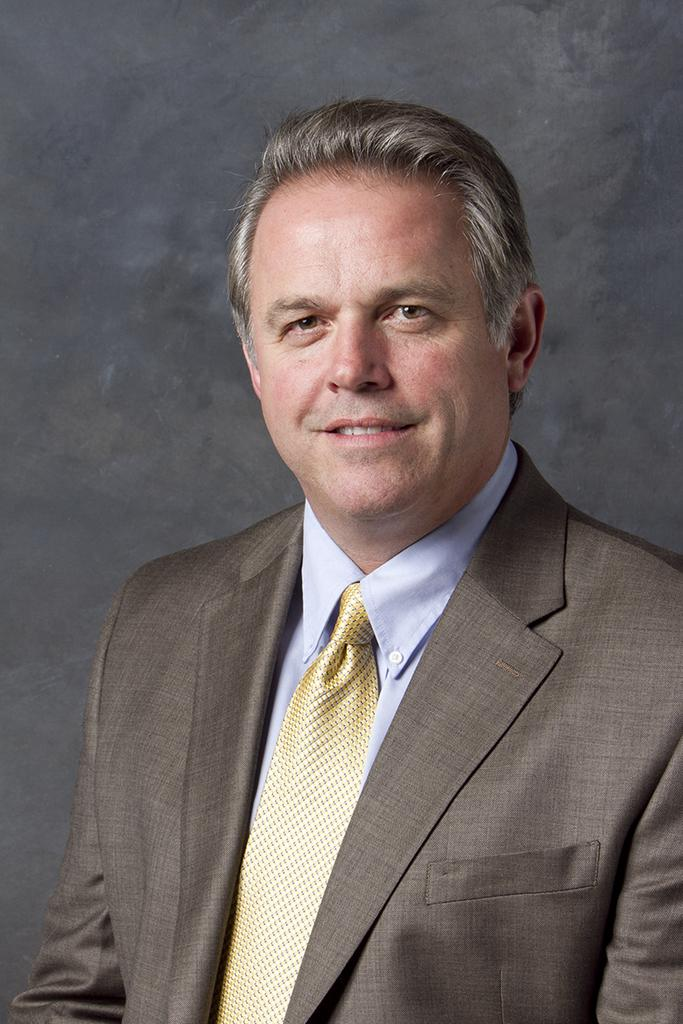What is the main subject of the image? The main subject of the image is a man. What is the man wearing? The man is wearing a brown suit, a golden tie, and a blue shirt. How is the man's facial expression in the image? The man is smiling in the image. What type of string is the man using to secure his payment in the image? There is no string or payment present in the image; it only features a man wearing a brown suit, a golden tie, and a blue shirt while smiling. 